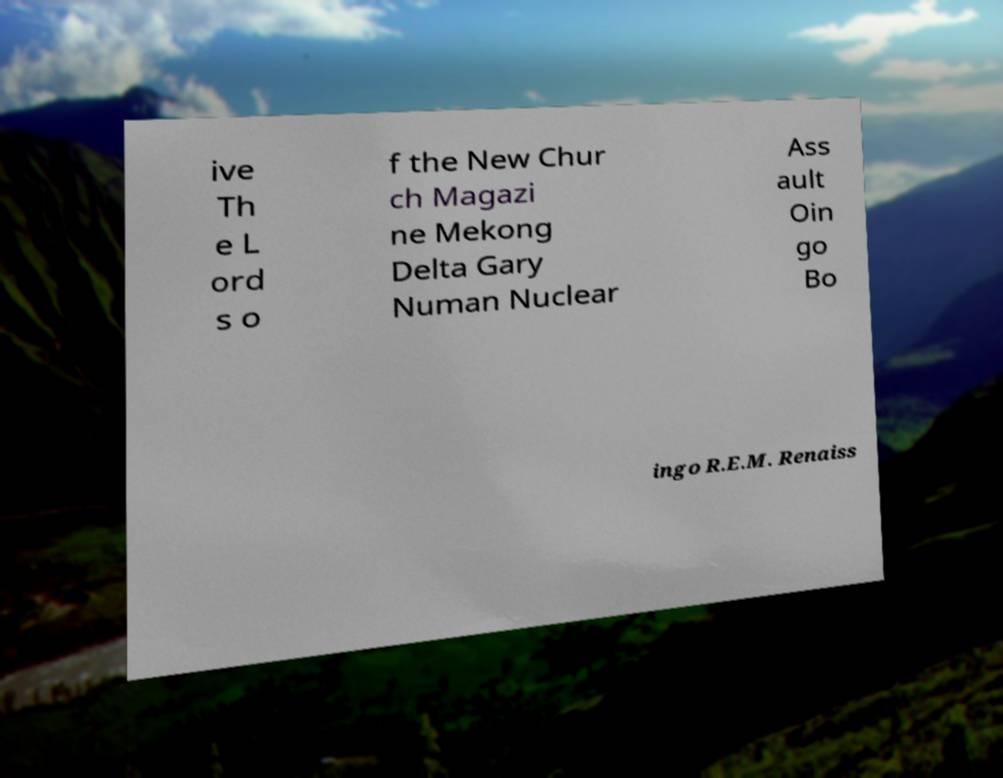Could you assist in decoding the text presented in this image and type it out clearly? ive Th e L ord s o f the New Chur ch Magazi ne Mekong Delta Gary Numan Nuclear Ass ault Oin go Bo ingo R.E.M. Renaiss 